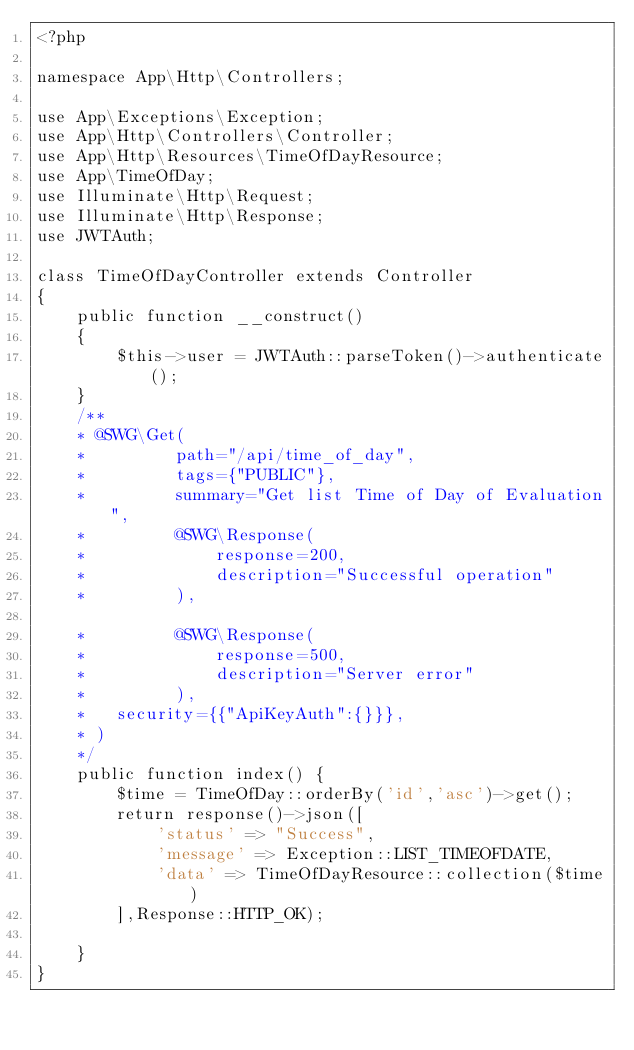Convert code to text. <code><loc_0><loc_0><loc_500><loc_500><_PHP_><?php

namespace App\Http\Controllers;

use App\Exceptions\Exception;
use App\Http\Controllers\Controller;
use App\Http\Resources\TimeOfDayResource;
use App\TimeOfDay;
use Illuminate\Http\Request;
use Illuminate\Http\Response;
use JWTAuth;

class TimeOfDayController extends Controller
{
    public function __construct()
    {
        $this->user = JWTAuth::parseToken()->authenticate();
    }
    /**
    * @SWG\Get(
    *         path="/api/time_of_day",
    *         tags={"PUBLIC"},
    *         summary="Get list Time of Day of Evaluation",
    *         @SWG\Response(
    *             response=200,
    *             description="Successful operation"
    *         ),

    *         @SWG\Response(
    *             response=500,
    *             description="Server error"
    *         ),
    *   security={{"ApiKeyAuth":{}}},
    * )
    */
    public function index() {
        $time = TimeOfDay::orderBy('id','asc')->get();
        return response()->json([
            'status' => "Success",
            'message' => Exception::LIST_TIMEOFDATE,
            'data' => TimeOfDayResource::collection($time)
        ],Response::HTTP_OK);
        
    }
}
</code> 